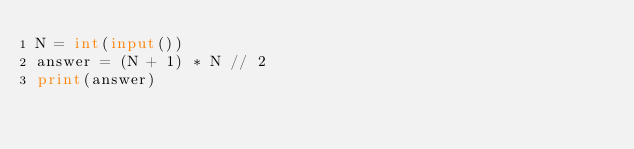Convert code to text. <code><loc_0><loc_0><loc_500><loc_500><_Python_>N = int(input())
answer = (N + 1) * N // 2
print(answer)
</code> 